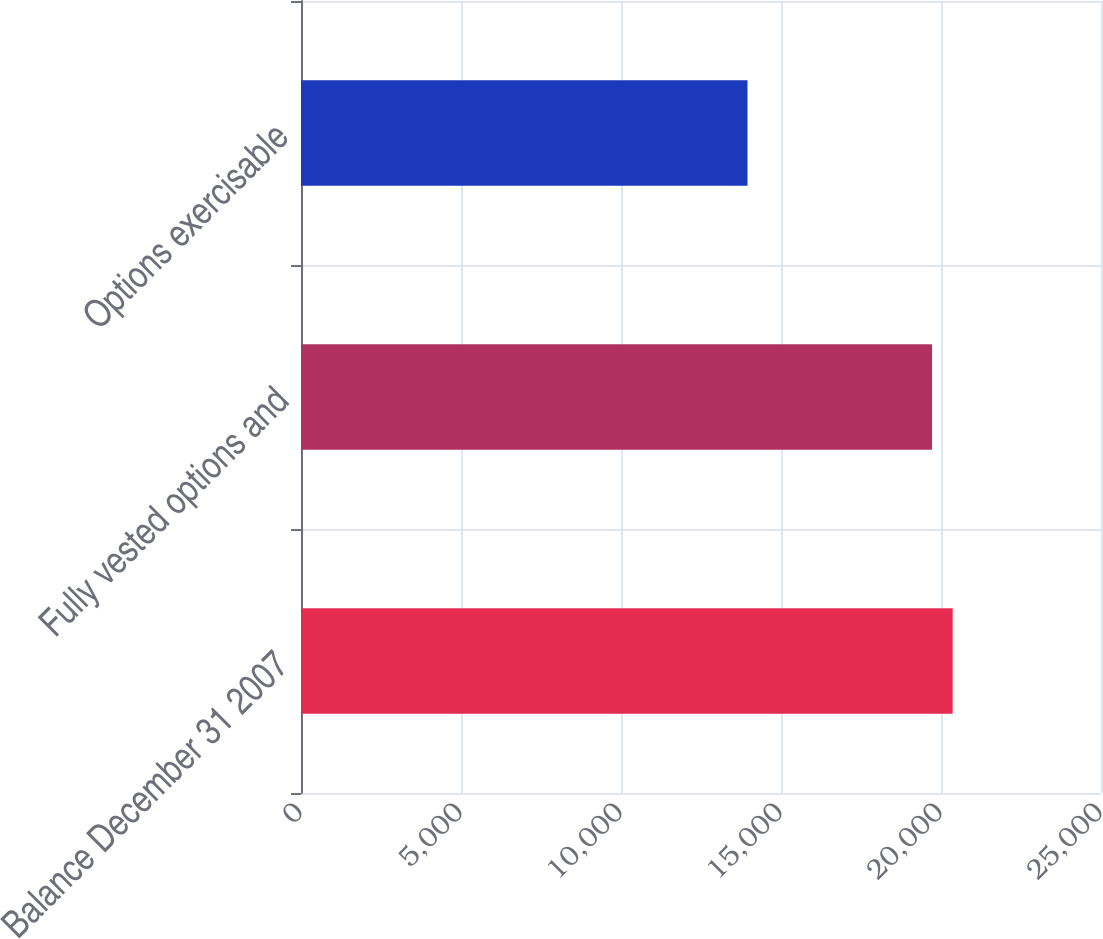Convert chart to OTSL. <chart><loc_0><loc_0><loc_500><loc_500><bar_chart><fcel>Balance December 31 2007<fcel>Fully vested options and<fcel>Options exercisable<nl><fcel>20365<fcel>19720<fcel>13953<nl></chart> 